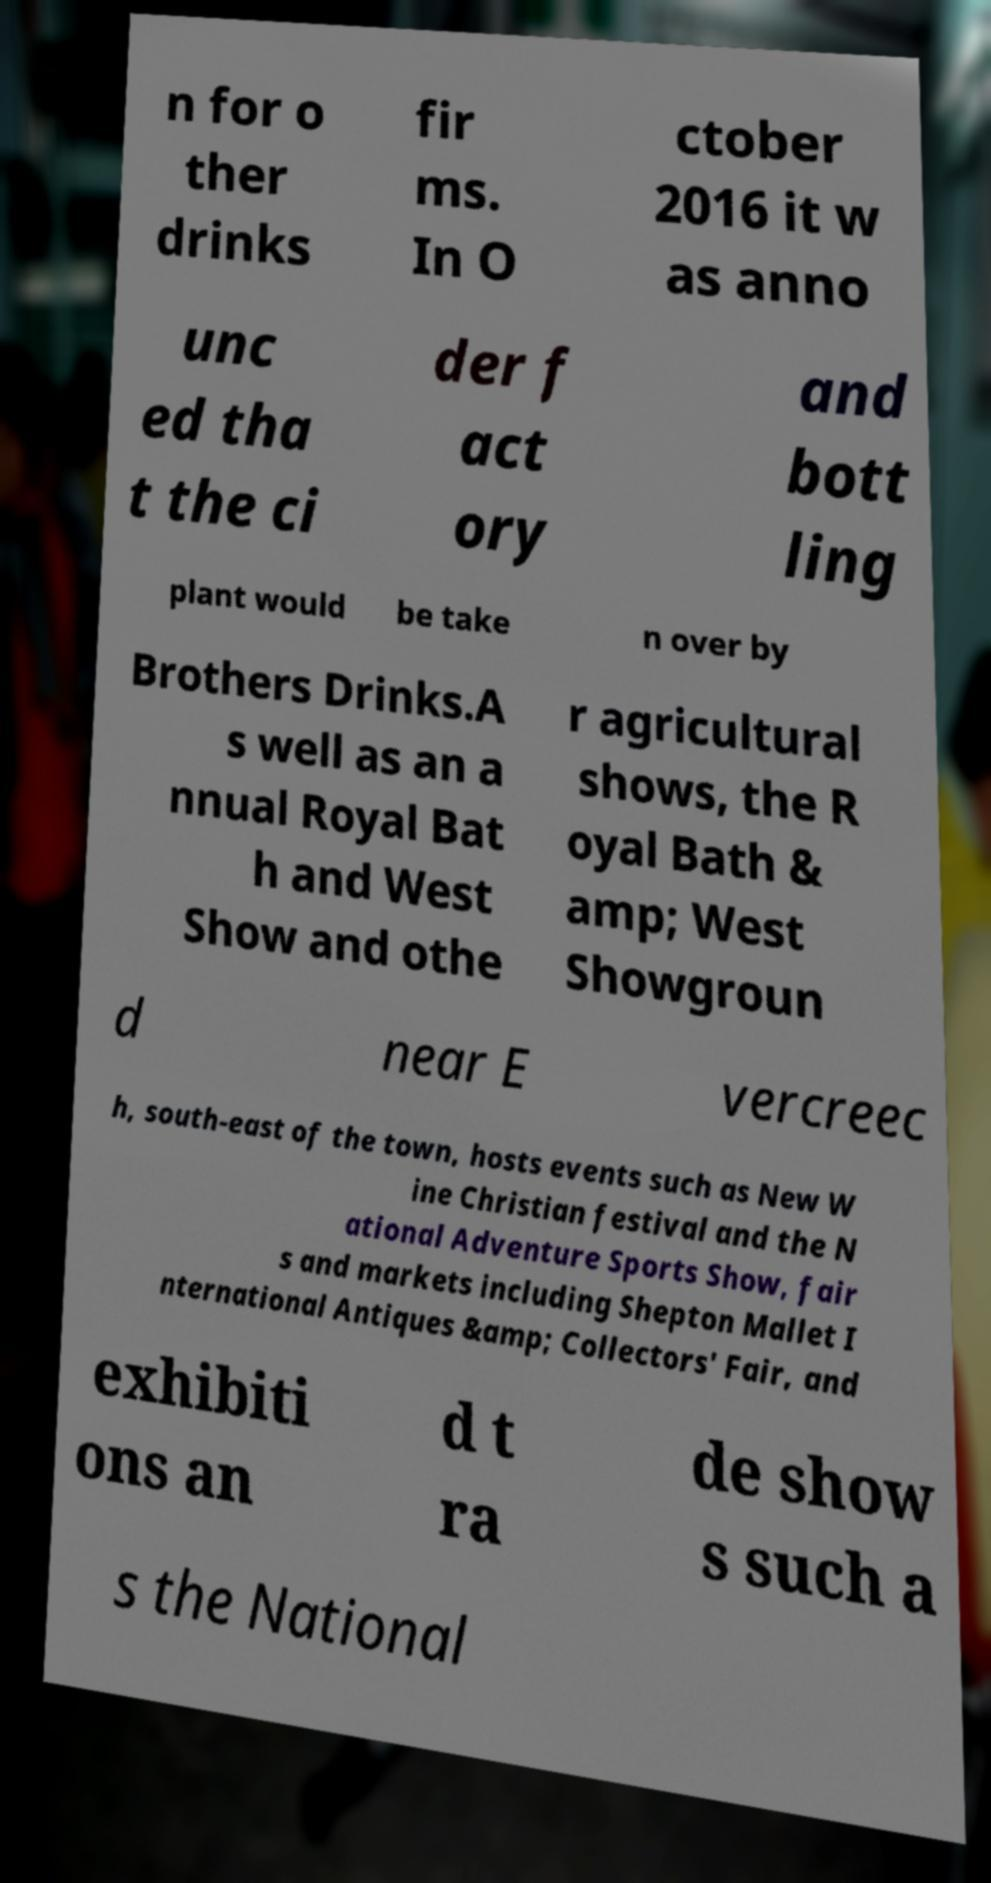What messages or text are displayed in this image? I need them in a readable, typed format. n for o ther drinks fir ms. In O ctober 2016 it w as anno unc ed tha t the ci der f act ory and bott ling plant would be take n over by Brothers Drinks.A s well as an a nnual Royal Bat h and West Show and othe r agricultural shows, the R oyal Bath & amp; West Showgroun d near E vercreec h, south-east of the town, hosts events such as New W ine Christian festival and the N ational Adventure Sports Show, fair s and markets including Shepton Mallet I nternational Antiques &amp; Collectors' Fair, and exhibiti ons an d t ra de show s such a s the National 